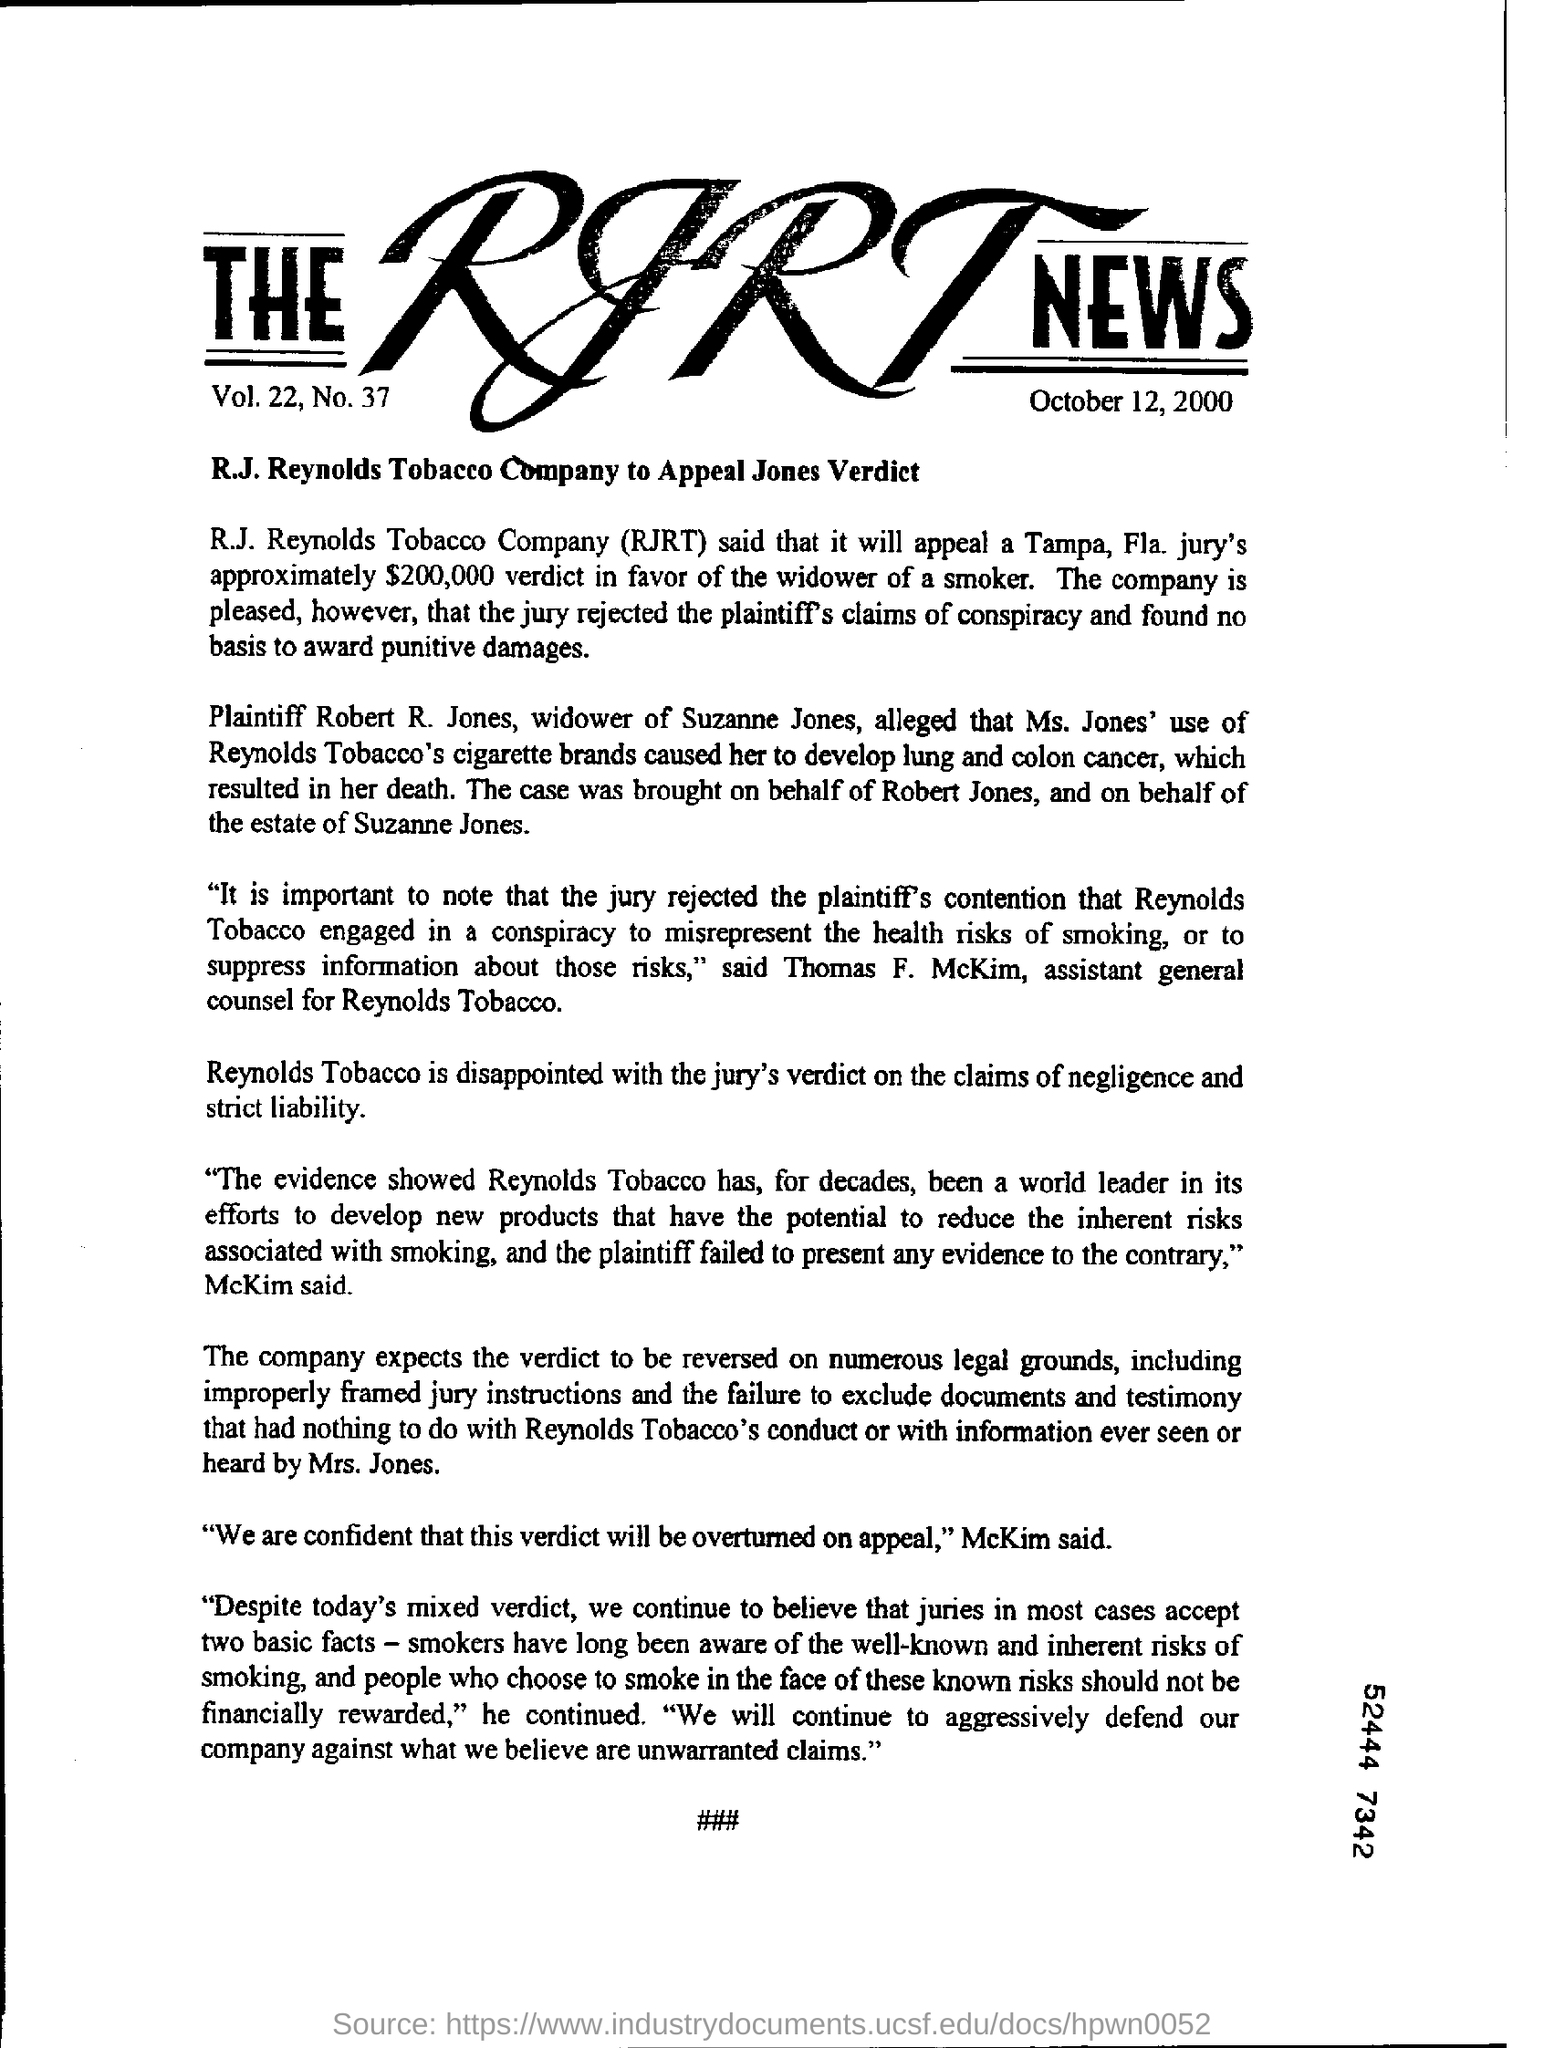Give some essential details in this illustration. Robert R. Jones is the widower of Suzanne Jones. Ms. Jones passed away as a result of lung and colon cancer. The date under the heading is October 12, 2000. The document is titled "THE RJRT NEWS. R.J. Reynolds Tobacco Company's full name is RJRT. 